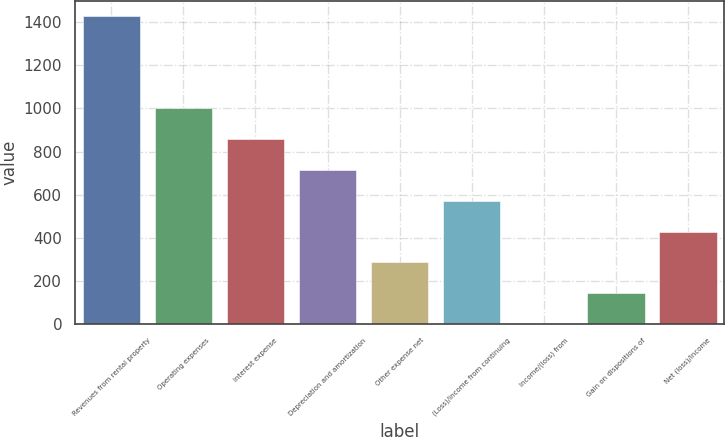<chart> <loc_0><loc_0><loc_500><loc_500><bar_chart><fcel>Revenues from rental property<fcel>Operating expenses<fcel>Interest expense<fcel>Depreciation and amortization<fcel>Other expense net<fcel>(Loss)/income from continuing<fcel>Income/(loss) from<fcel>Gain on dispositions of<fcel>Net (loss)/income<nl><fcel>1427.6<fcel>999.68<fcel>857.04<fcel>714.4<fcel>286.48<fcel>571.76<fcel>1.2<fcel>143.84<fcel>429.12<nl></chart> 